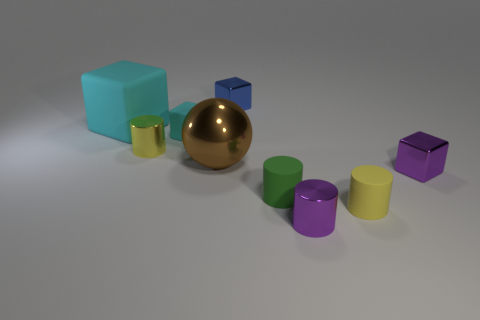Subtract all purple blocks. How many blocks are left? 3 Subtract all small yellow matte cylinders. How many cylinders are left? 3 Subtract all red blocks. Subtract all blue spheres. How many blocks are left? 4 Subtract all balls. How many objects are left? 8 Add 9 blue shiny blocks. How many blue shiny blocks are left? 10 Add 8 gray matte objects. How many gray matte objects exist? 8 Subtract 0 blue cylinders. How many objects are left? 9 Subtract all tiny yellow rubber cubes. Subtract all blue things. How many objects are left? 8 